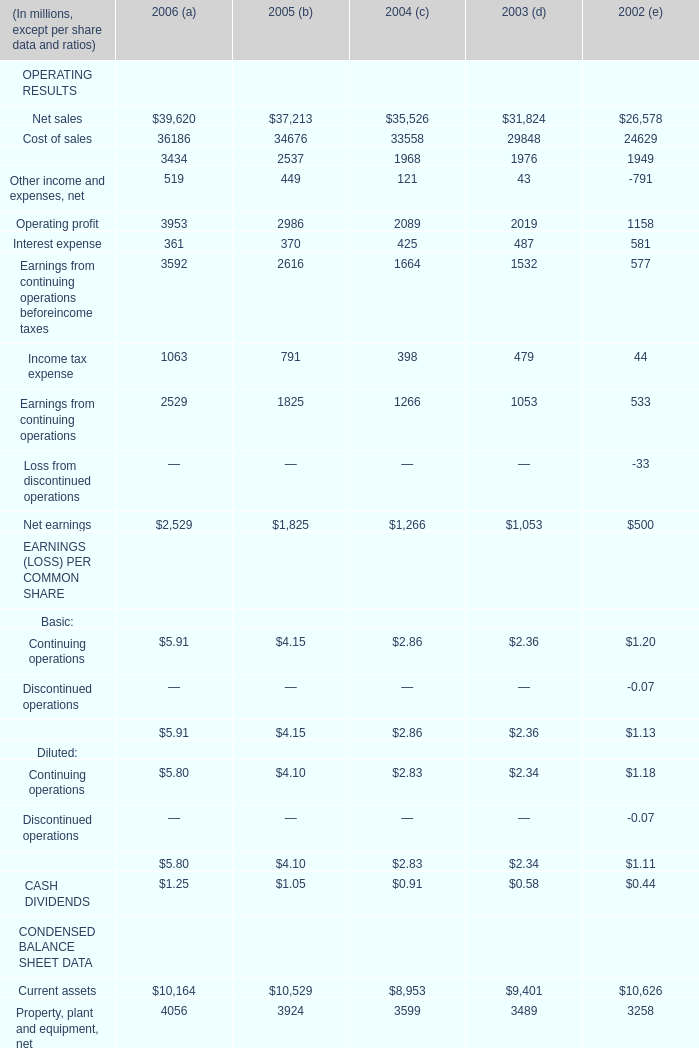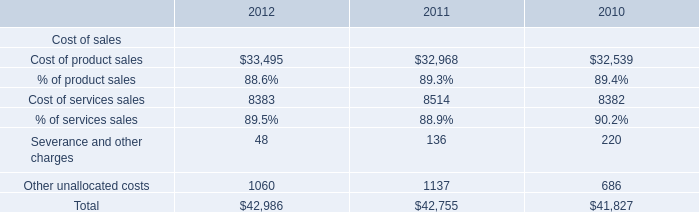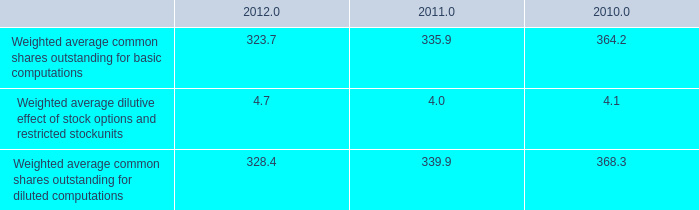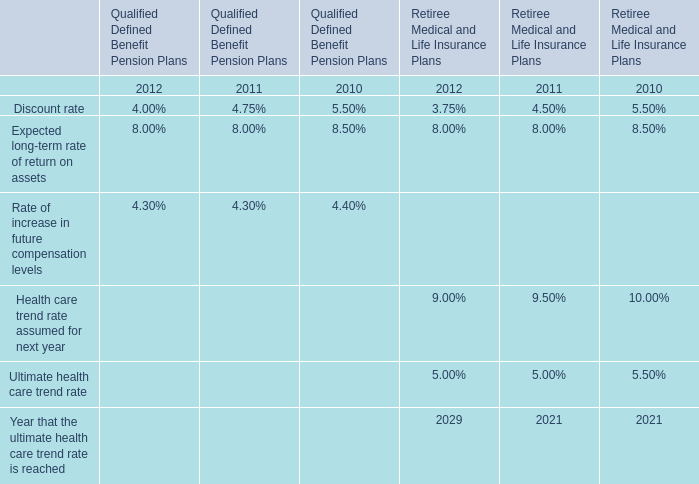What is the total value of Cost of sales, Net sales, Other income and expenses, net and Operating profit in 2006? (in million) 
Computations: (((39620 + 36186) + 519) + 3953)
Answer: 80278.0. 